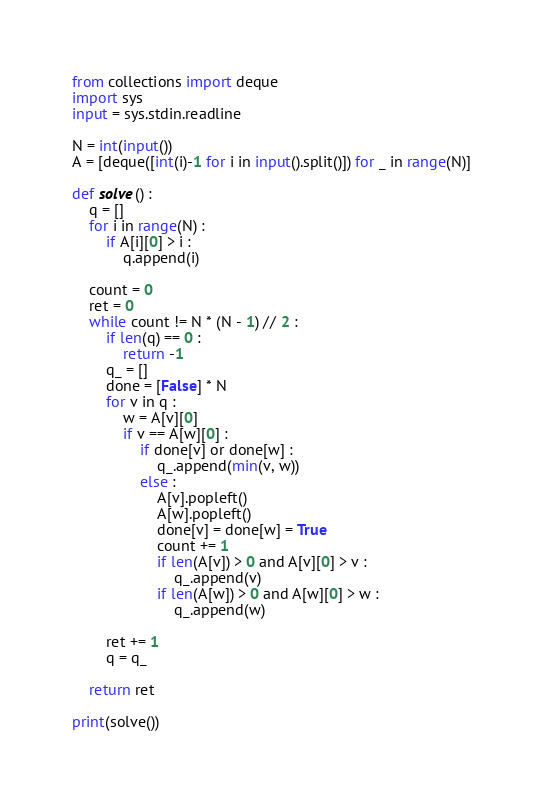Convert code to text. <code><loc_0><loc_0><loc_500><loc_500><_Python_>from collections import deque
import sys
input = sys.stdin.readline

N = int(input())
A = [deque([int(i)-1 for i in input().split()]) for _ in range(N)]

def solve() :
    q = []
    for i in range(N) :
        if A[i][0] > i :
            q.append(i)
            
    count = 0
    ret = 0
    while count != N * (N - 1) // 2 :
        if len(q) == 0 :
            return -1
        q_ = []
        done = [False] * N
        for v in q :
            w = A[v][0]
            if v == A[w][0] :
                if done[v] or done[w] :
                    q_.append(min(v, w))
                else :
                    A[v].popleft()
                    A[w].popleft()
                    done[v] = done[w] = True
                    count += 1
                    if len(A[v]) > 0 and A[v][0] > v :
                        q_.append(v)
                    if len(A[w]) > 0 and A[w][0] > w :
                        q_.append(w)        

        ret += 1
        q = q_
        
    return ret
    
print(solve())
</code> 